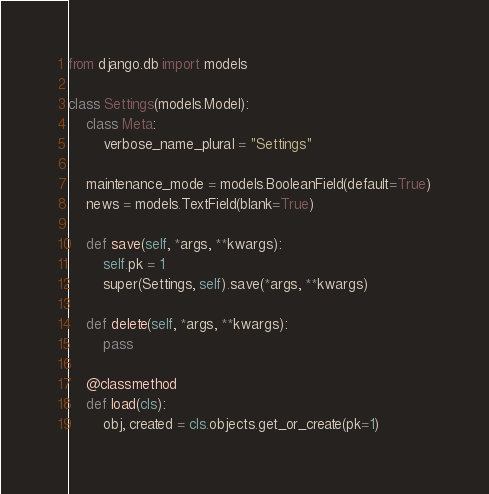<code> <loc_0><loc_0><loc_500><loc_500><_Python_>from django.db import models

class Settings(models.Model):
    class Meta:
        verbose_name_plural = "Settings"

    maintenance_mode = models.BooleanField(default=True)
    news = models.TextField(blank=True)

    def save(self, *args, **kwargs):
        self.pk = 1
        super(Settings, self).save(*args, **kwargs)

    def delete(self, *args, **kwargs):
        pass

    @classmethod
    def load(cls):
        obj, created = cls.objects.get_or_create(pk=1)</code> 